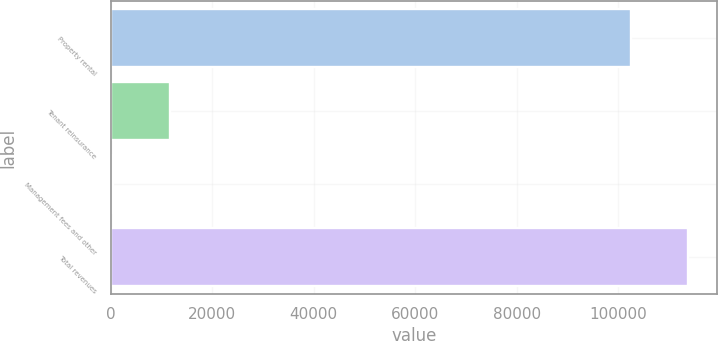Convert chart. <chart><loc_0><loc_0><loc_500><loc_500><bar_chart><fcel>Property rental<fcel>Tenant reinsurance<fcel>Management fees and other<fcel>Total revenues<nl><fcel>102487<fcel>11730.1<fcel>463<fcel>113754<nl></chart> 